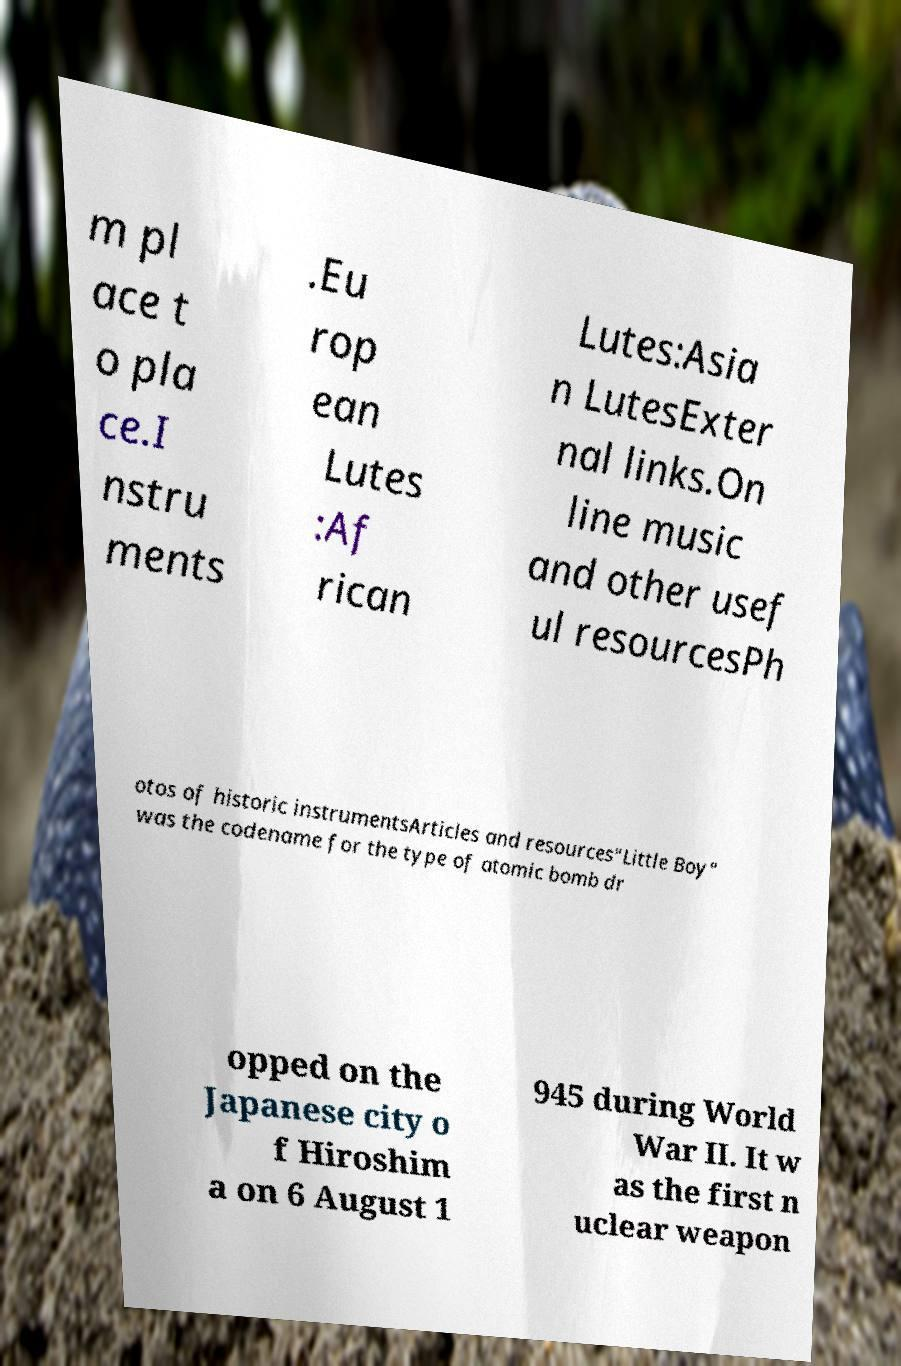I need the written content from this picture converted into text. Can you do that? m pl ace t o pla ce.I nstru ments .Eu rop ean Lutes :Af rican Lutes:Asia n LutesExter nal links.On line music and other usef ul resourcesPh otos of historic instrumentsArticles and resources"Little Boy" was the codename for the type of atomic bomb dr opped on the Japanese city o f Hiroshim a on 6 August 1 945 during World War II. It w as the first n uclear weapon 